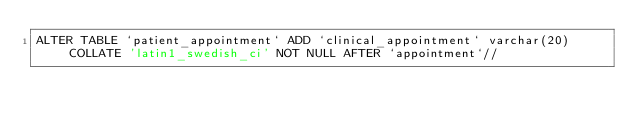<code> <loc_0><loc_0><loc_500><loc_500><_SQL_>ALTER TABLE `patient_appointment` ADD `clinical_appointment` varchar(20) COLLATE 'latin1_swedish_ci' NOT NULL AFTER `appointment`//</code> 